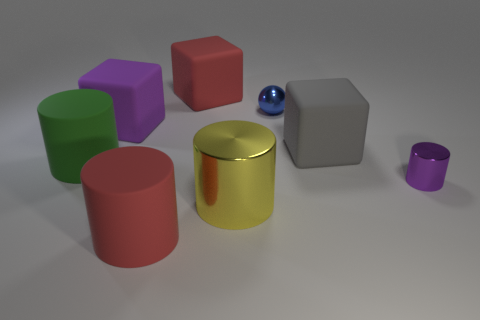Is there anything else that is the same shape as the small blue metallic thing?
Offer a very short reply. No. What size is the purple shiny object that is the same shape as the yellow metal thing?
Your answer should be very brief. Small. Is the color of the tiny cylinder the same as the big cube that is left of the large red cylinder?
Offer a very short reply. Yes. What number of other things are the same size as the yellow thing?
Your answer should be very brief. 5. What shape is the red thing on the right side of the large red thing on the left side of the large red rubber thing that is behind the yellow object?
Your answer should be compact. Cube. Is the size of the blue shiny ball the same as the purple object that is to the left of the tiny blue metal ball?
Your answer should be very brief. No. The big cube that is both in front of the ball and to the left of the big gray object is what color?
Provide a short and direct response. Purple. What number of other things are the same shape as the big green thing?
Make the answer very short. 3. Is the color of the small cylinder that is in front of the purple rubber cube the same as the large cube left of the large red rubber block?
Your answer should be compact. Yes. Do the purple thing behind the green rubber thing and the metal object that is behind the tiny purple thing have the same size?
Your answer should be very brief. No. 